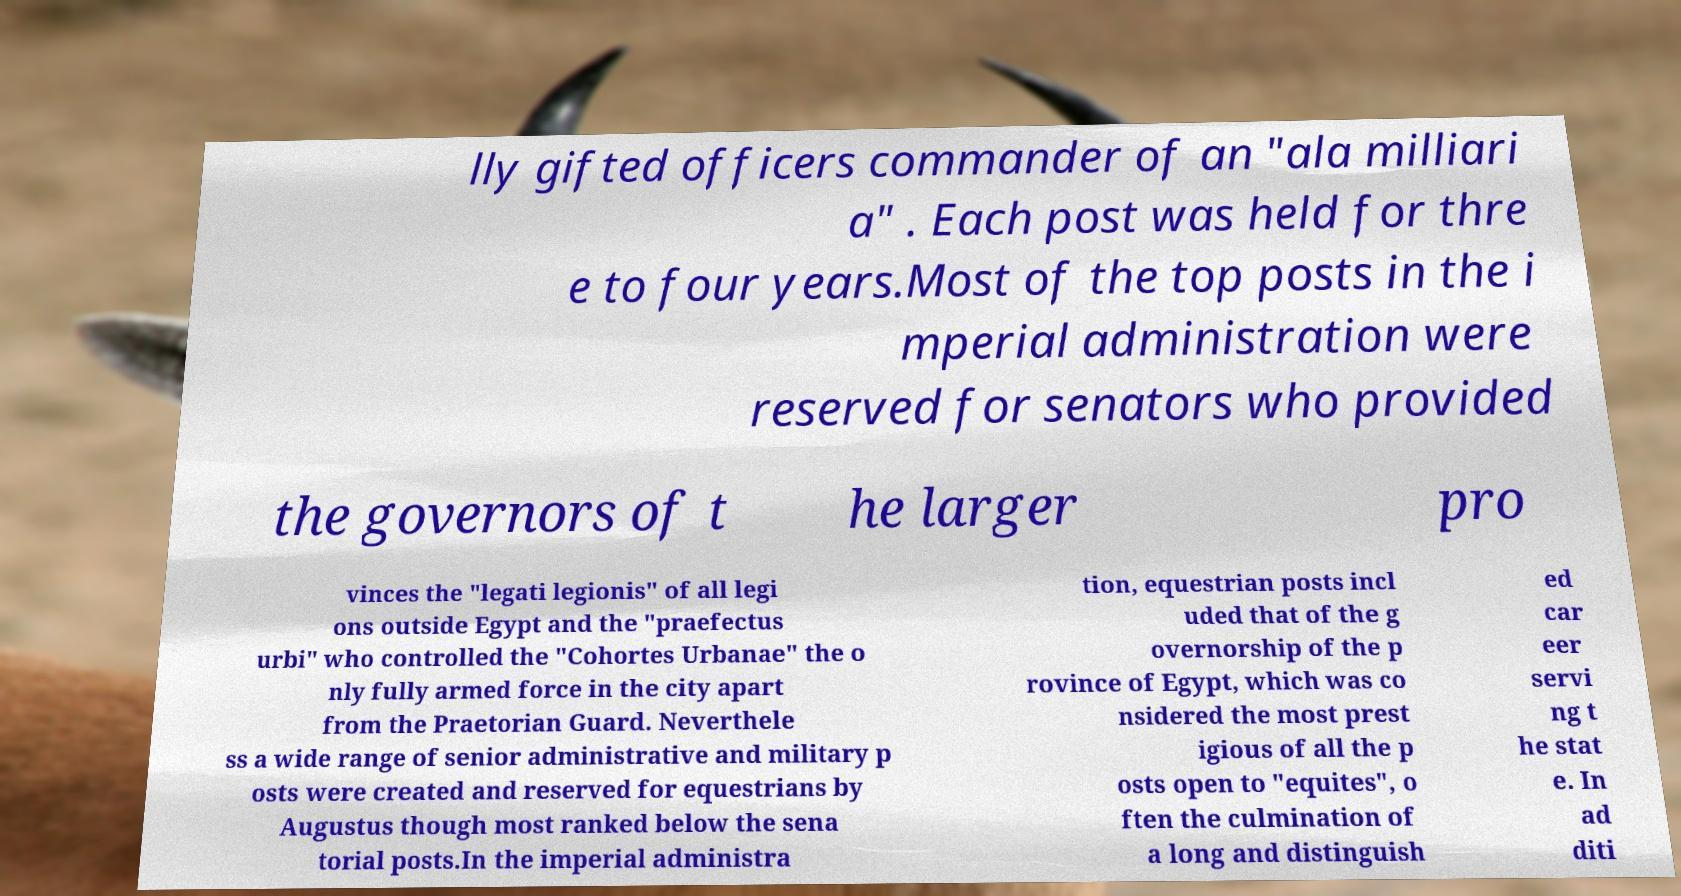Could you assist in decoding the text presented in this image and type it out clearly? lly gifted officers commander of an "ala milliari a" . Each post was held for thre e to four years.Most of the top posts in the i mperial administration were reserved for senators who provided the governors of t he larger pro vinces the "legati legionis" of all legi ons outside Egypt and the "praefectus urbi" who controlled the "Cohortes Urbanae" the o nly fully armed force in the city apart from the Praetorian Guard. Neverthele ss a wide range of senior administrative and military p osts were created and reserved for equestrians by Augustus though most ranked below the sena torial posts.In the imperial administra tion, equestrian posts incl uded that of the g overnorship of the p rovince of Egypt, which was co nsidered the most prest igious of all the p osts open to "equites", o ften the culmination of a long and distinguish ed car eer servi ng t he stat e. In ad diti 